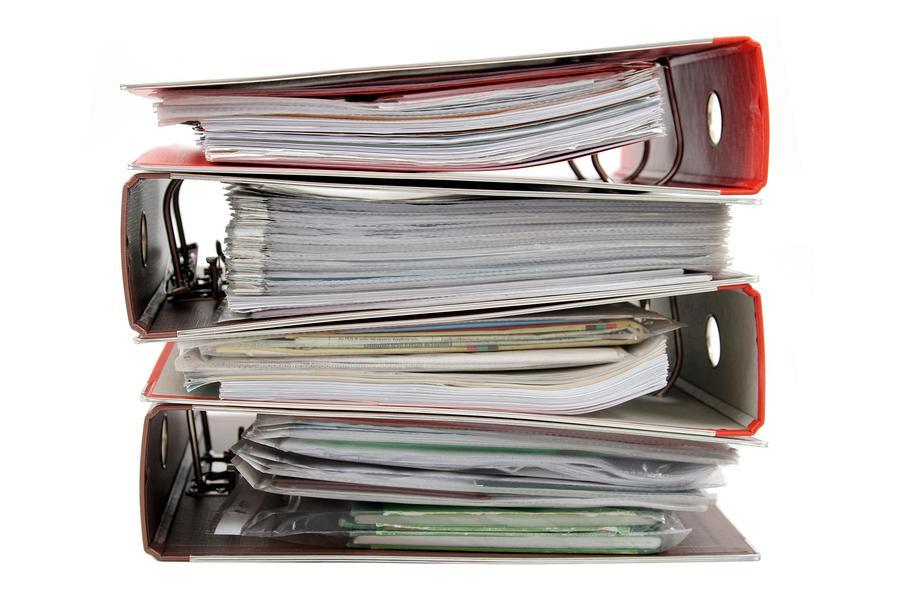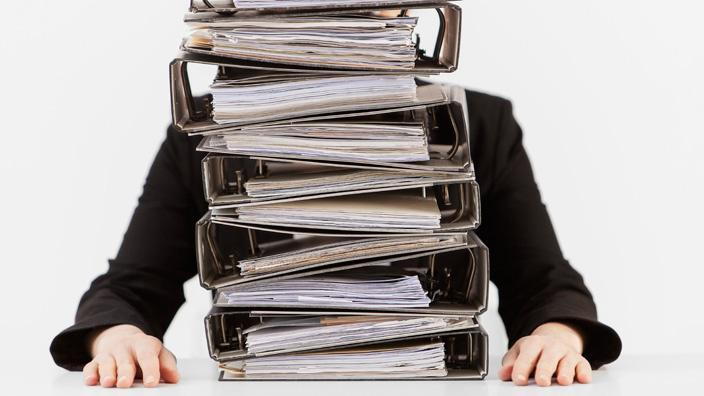The first image is the image on the left, the second image is the image on the right. Examine the images to the left and right. Is the description "An image contains no more than five binders, which are stacked alternately, front to back." accurate? Answer yes or no. Yes. The first image is the image on the left, the second image is the image on the right. Considering the images on both sides, is "In one image, no more than five notebooks filled with paper contents are stacked with ring ends on alternating sides, while a second image shows similar notebooks and contents in a larger stack." valid? Answer yes or no. Yes. 